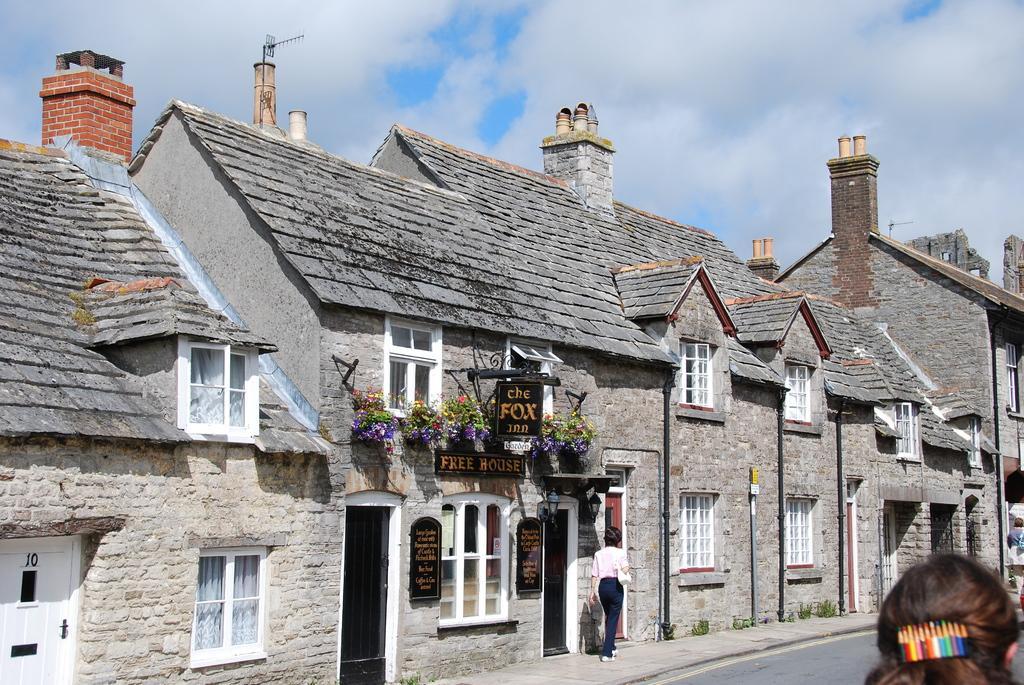Can you describe this image briefly? Here in this picture we can see houses, stores with windows and doors on it and we can also see people standing and walking on the road and in the middle we can see flower plants present on a store and we can also see a hoarding board present and we can see clouds in the sky. 